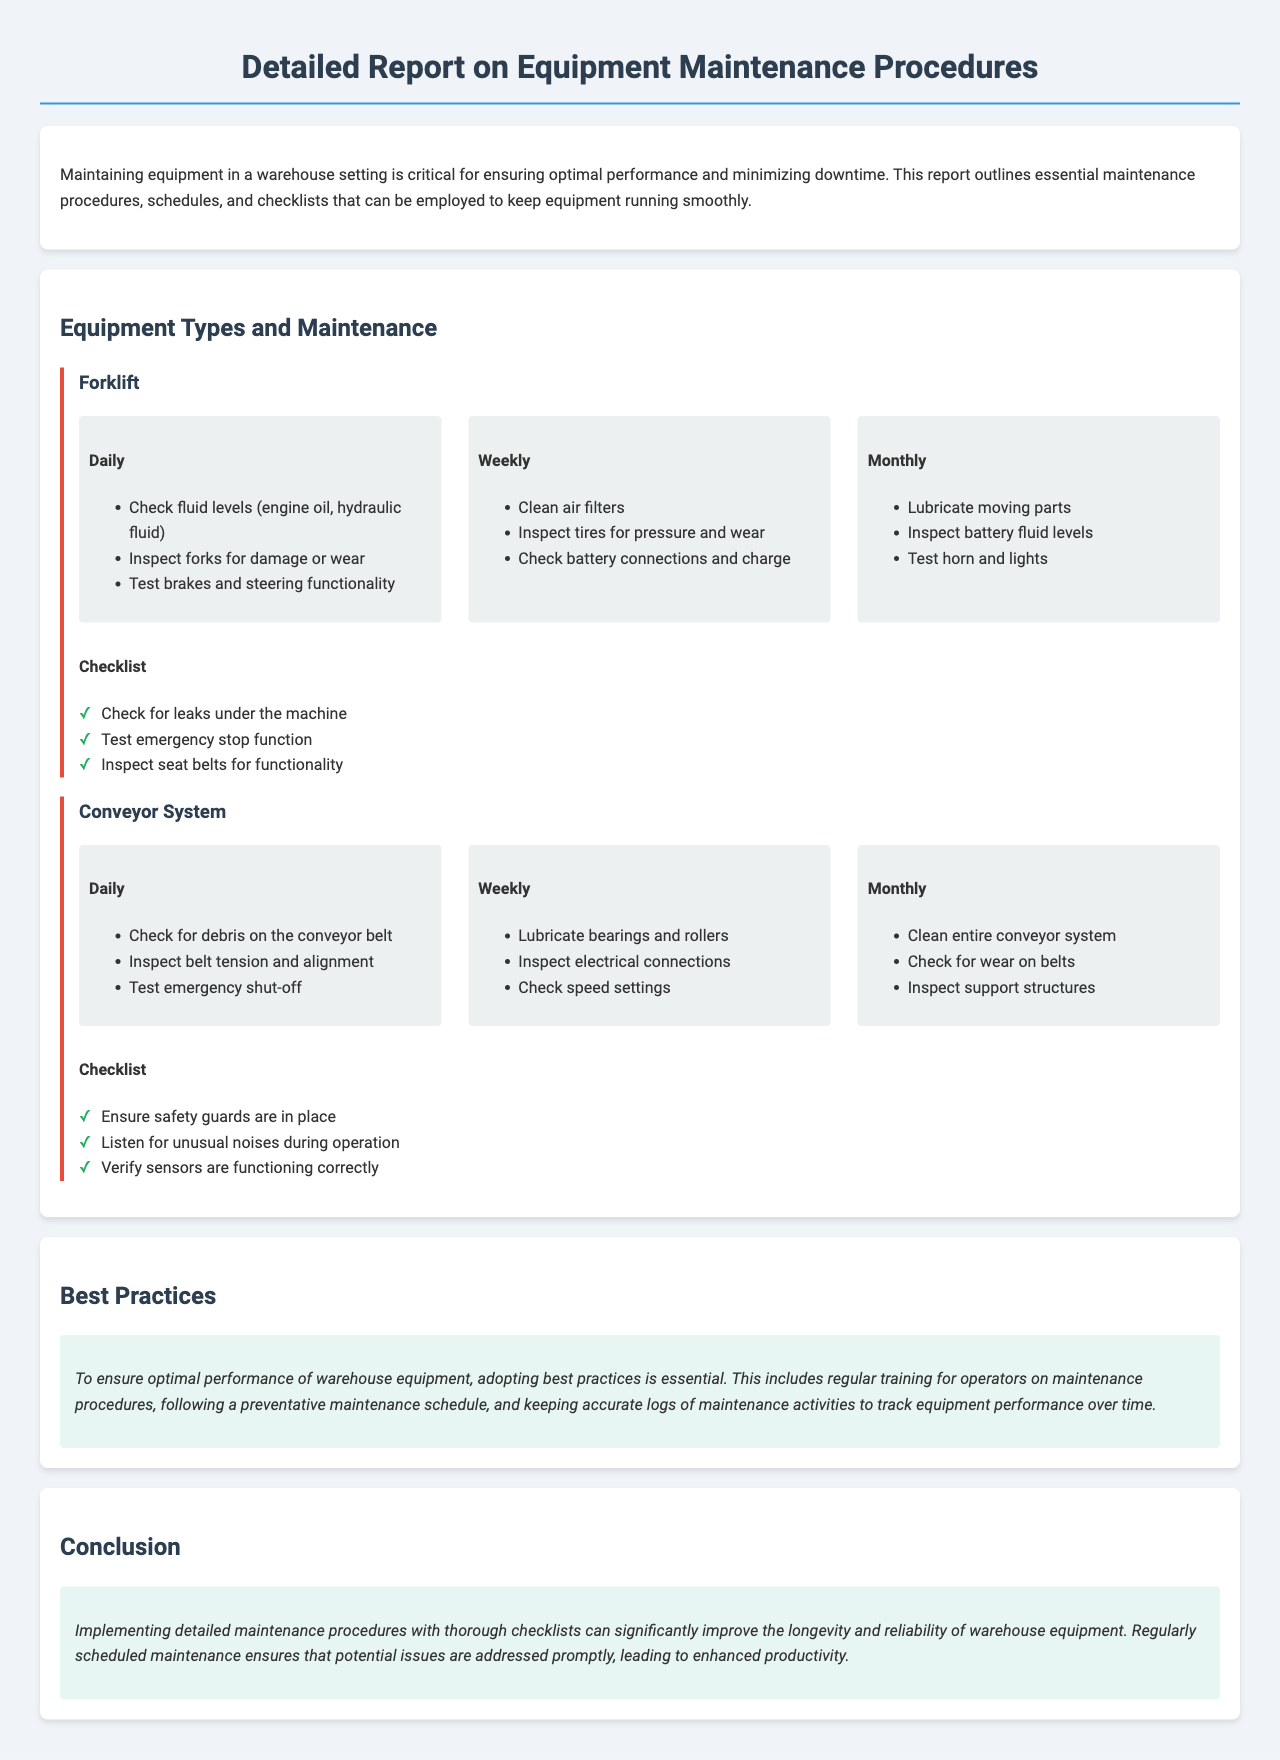What is the title of the report? The title of the report is stated at the top of the document.
Answer: Detailed Report on Equipment Maintenance Procedures How often should the fluid levels be checked for a forklift? This is specified under the daily maintenance schedule for the forklift.
Answer: Daily What is one task to be performed weekly on the conveyor system? The document specifies tasks for each equipment type and schedule.
Answer: Lubricate bearings and rollers What type of maintenance does the checklist for the forklift include? The checklist includes specific items that need to be checked regularly for the forklift.
Answer: Check for leaks under the machine What is recommended under best practices for equipment maintenance? The best practices section gives guidance for ensuring optimal performance.
Answer: Regular training for operators How many monthly tasks are listed for the forklift? The document outlines specific tasks under the monthly maintenance schedule.
Answer: Three What should be inspected daily on the conveyor system? This is included in the daily maintenance schedule for the conveyor system.
Answer: Check for debris on the conveyor belt What color is used for safety checks in the checklist? The checklist items have a specific styling for indicating tasks completed.
Answer: Green (✓) What is the significance of implementing maintenance procedures? The conclusion section summarizes the importance of these procedures.
Answer: Improve longevity and reliability 